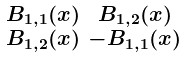Convert formula to latex. <formula><loc_0><loc_0><loc_500><loc_500>\begin{smallmatrix} B _ { 1 , 1 } ( x ) & B _ { 1 , 2 } ( x ) \\ B _ { 1 , 2 } ( x ) & - B _ { 1 , 1 } ( x ) \end{smallmatrix}</formula> 